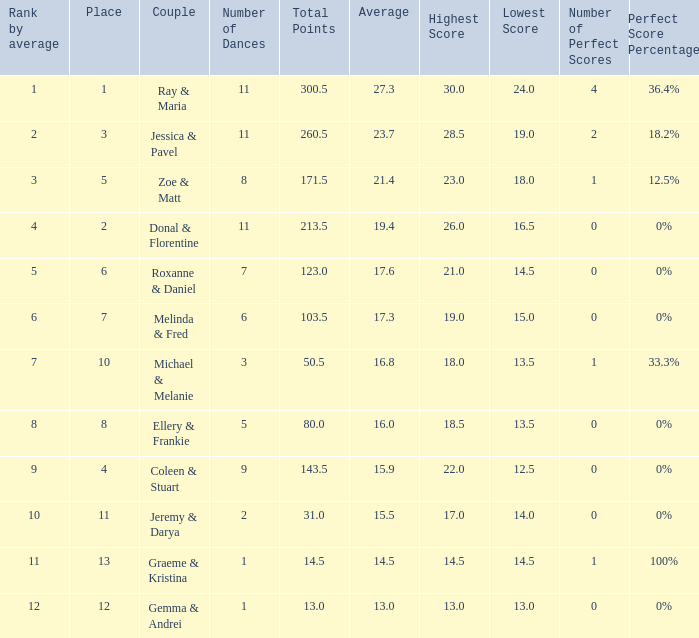What is the couples name where the average is 15.9? Coleen & Stuart. 